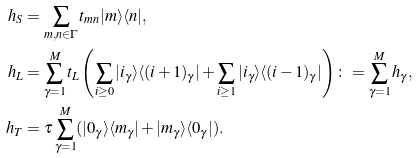Convert formula to latex. <formula><loc_0><loc_0><loc_500><loc_500>h _ { S } & = \sum _ { m , n \in \Gamma } t _ { m n } | m \rangle \langle n | , \\ h _ { L } & = \sum _ { \gamma = 1 } ^ { M } t _ { L } \left ( \sum _ { i \geq 0 } | i _ { \gamma } \rangle \langle ( i + 1 ) _ { \gamma } | + \sum _ { i \geq 1 } | i _ { \gamma } \rangle \langle ( i - 1 ) _ { \gamma } | \right ) \colon = \sum _ { \gamma = 1 } ^ { M } h _ { \gamma } , \\ h _ { T } & = \tau \sum _ { \gamma = 1 } ^ { M } ( | 0 _ { \gamma } \rangle \langle m _ { \gamma } | + | m _ { \gamma } \rangle \langle 0 _ { \gamma } | ) .</formula> 